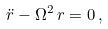Convert formula to latex. <formula><loc_0><loc_0><loc_500><loc_500>\ddot { r } - \Omega ^ { 2 } \, r = 0 \, ,</formula> 